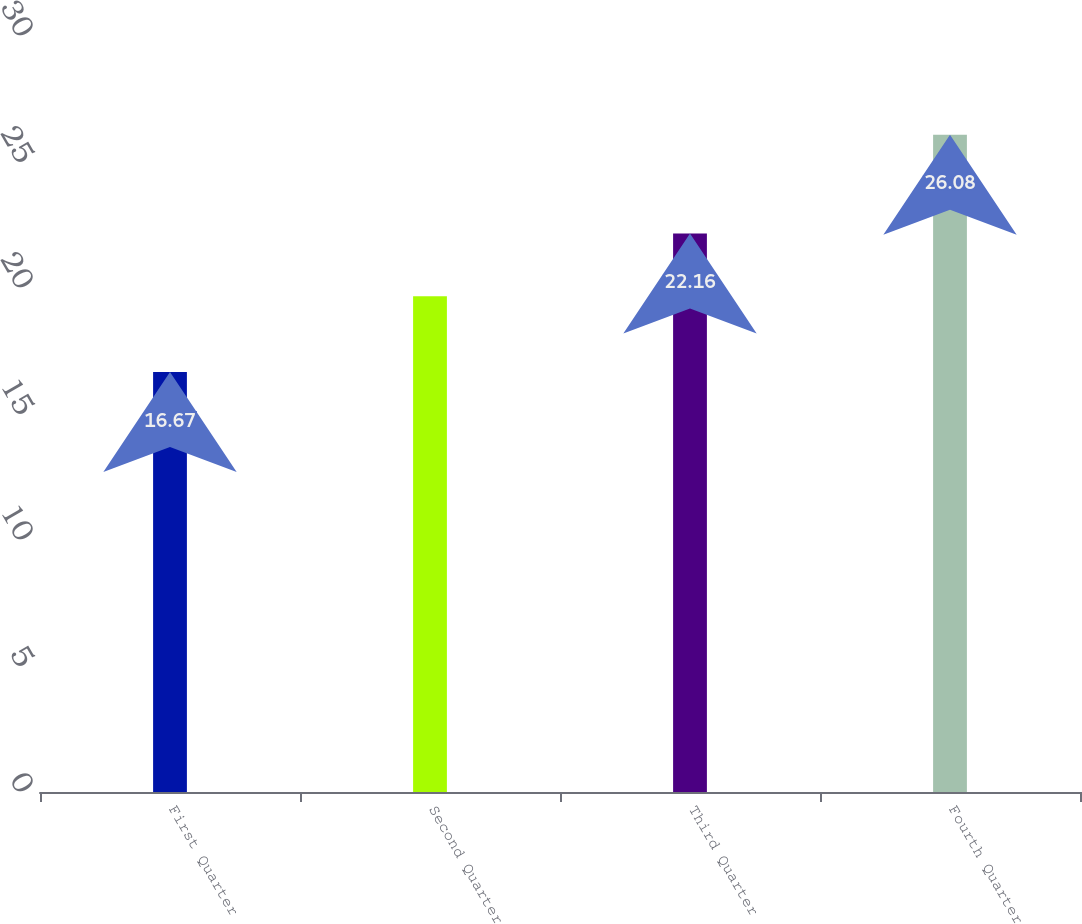Convert chart to OTSL. <chart><loc_0><loc_0><loc_500><loc_500><bar_chart><fcel>First Quarter<fcel>Second Quarter<fcel>Third Quarter<fcel>Fourth Quarter<nl><fcel>16.67<fcel>19.67<fcel>22.16<fcel>26.08<nl></chart> 